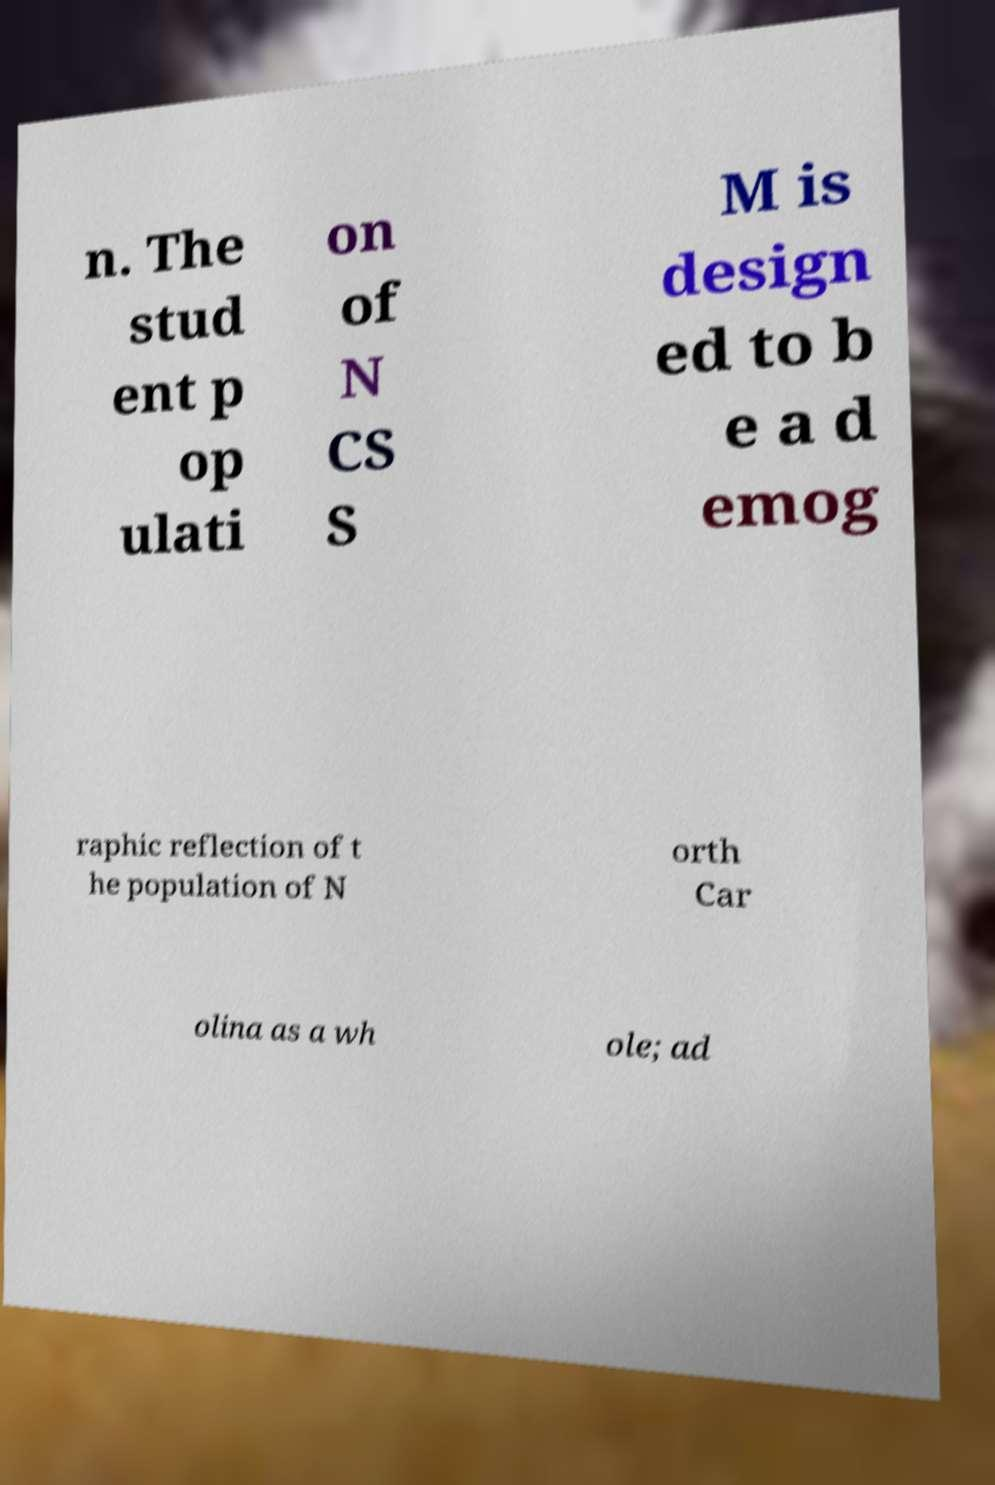What messages or text are displayed in this image? I need them in a readable, typed format. n. The stud ent p op ulati on of N CS S M is design ed to b e a d emog raphic reflection of t he population of N orth Car olina as a wh ole; ad 